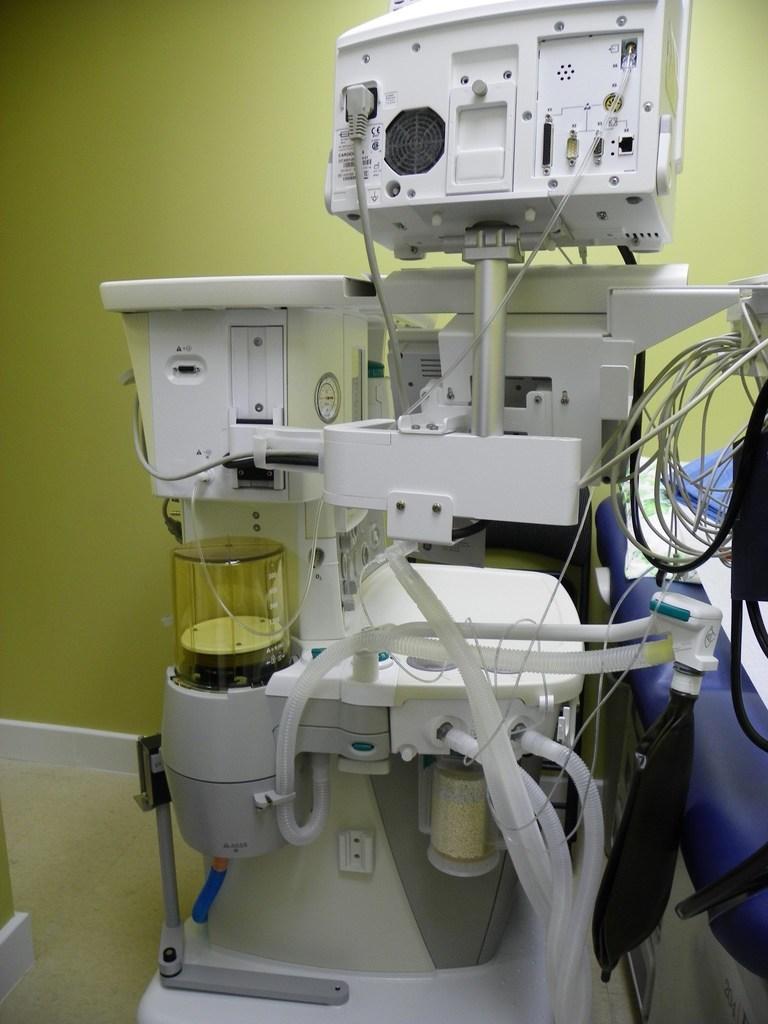How would you summarize this image in a sentence or two? In this picture I can see few equipment and wires in front. In the background I can see the yellow color wall. On the right side of this picture, I can see the blue color thing. 